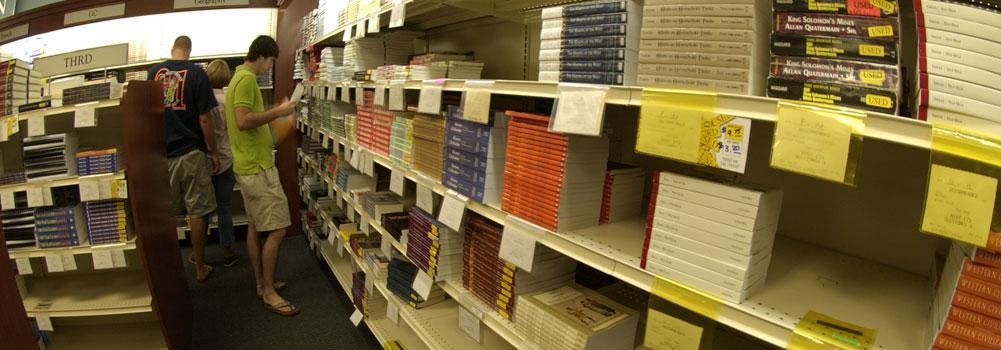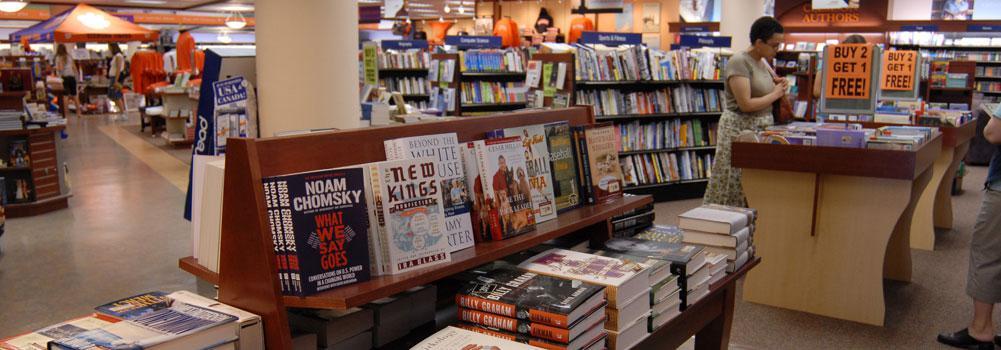The first image is the image on the left, the second image is the image on the right. Assess this claim about the two images: "One or more customers are shown in a bookstore.". Correct or not? Answer yes or no. Yes. 